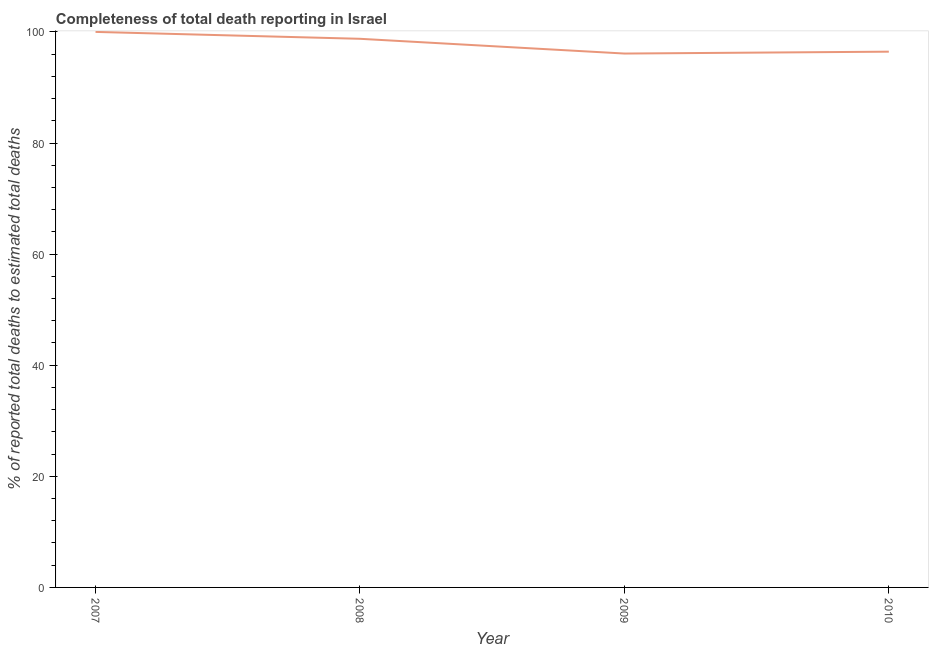What is the completeness of total death reports in 2008?
Provide a short and direct response. 98.76. Across all years, what is the minimum completeness of total death reports?
Your response must be concise. 96.11. In which year was the completeness of total death reports maximum?
Offer a very short reply. 2007. In which year was the completeness of total death reports minimum?
Ensure brevity in your answer.  2009. What is the sum of the completeness of total death reports?
Your response must be concise. 391.31. What is the difference between the completeness of total death reports in 2008 and 2009?
Make the answer very short. 2.65. What is the average completeness of total death reports per year?
Provide a short and direct response. 97.83. What is the median completeness of total death reports?
Ensure brevity in your answer.  97.6. In how many years, is the completeness of total death reports greater than 88 %?
Provide a succinct answer. 4. What is the ratio of the completeness of total death reports in 2007 to that in 2008?
Offer a terse response. 1.01. What is the difference between the highest and the second highest completeness of total death reports?
Your answer should be compact. 1.24. Is the sum of the completeness of total death reports in 2009 and 2010 greater than the maximum completeness of total death reports across all years?
Provide a succinct answer. Yes. What is the difference between the highest and the lowest completeness of total death reports?
Make the answer very short. 3.89. In how many years, is the completeness of total death reports greater than the average completeness of total death reports taken over all years?
Offer a terse response. 2. How many lines are there?
Ensure brevity in your answer.  1. Are the values on the major ticks of Y-axis written in scientific E-notation?
Make the answer very short. No. Does the graph contain grids?
Keep it short and to the point. No. What is the title of the graph?
Your answer should be very brief. Completeness of total death reporting in Israel. What is the label or title of the Y-axis?
Provide a succinct answer. % of reported total deaths to estimated total deaths. What is the % of reported total deaths to estimated total deaths in 2008?
Ensure brevity in your answer.  98.76. What is the % of reported total deaths to estimated total deaths in 2009?
Your answer should be compact. 96.11. What is the % of reported total deaths to estimated total deaths in 2010?
Keep it short and to the point. 96.44. What is the difference between the % of reported total deaths to estimated total deaths in 2007 and 2008?
Offer a very short reply. 1.24. What is the difference between the % of reported total deaths to estimated total deaths in 2007 and 2009?
Give a very brief answer. 3.89. What is the difference between the % of reported total deaths to estimated total deaths in 2007 and 2010?
Your answer should be very brief. 3.56. What is the difference between the % of reported total deaths to estimated total deaths in 2008 and 2009?
Make the answer very short. 2.65. What is the difference between the % of reported total deaths to estimated total deaths in 2008 and 2010?
Offer a very short reply. 2.32. What is the difference between the % of reported total deaths to estimated total deaths in 2009 and 2010?
Your response must be concise. -0.34. What is the ratio of the % of reported total deaths to estimated total deaths in 2007 to that in 2009?
Your answer should be compact. 1.04. What is the ratio of the % of reported total deaths to estimated total deaths in 2008 to that in 2009?
Provide a short and direct response. 1.03. 